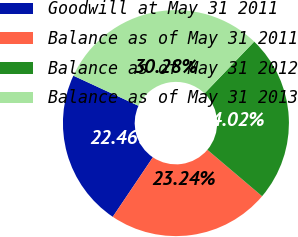<chart> <loc_0><loc_0><loc_500><loc_500><pie_chart><fcel>Goodwill at May 31 2011<fcel>Balance as of May 31 2011<fcel>Balance as of May 31 2012<fcel>Balance as of May 31 2013<nl><fcel>22.46%<fcel>23.24%<fcel>24.02%<fcel>30.28%<nl></chart> 